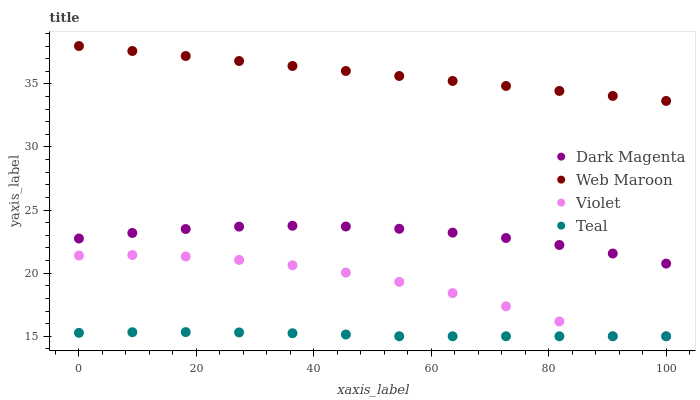Does Teal have the minimum area under the curve?
Answer yes or no. Yes. Does Web Maroon have the maximum area under the curve?
Answer yes or no. Yes. Does Dark Magenta have the minimum area under the curve?
Answer yes or no. No. Does Dark Magenta have the maximum area under the curve?
Answer yes or no. No. Is Web Maroon the smoothest?
Answer yes or no. Yes. Is Violet the roughest?
Answer yes or no. Yes. Is Dark Magenta the smoothest?
Answer yes or no. No. Is Dark Magenta the roughest?
Answer yes or no. No. Does Teal have the lowest value?
Answer yes or no. Yes. Does Dark Magenta have the lowest value?
Answer yes or no. No. Does Web Maroon have the highest value?
Answer yes or no. Yes. Does Dark Magenta have the highest value?
Answer yes or no. No. Is Teal less than Dark Magenta?
Answer yes or no. Yes. Is Web Maroon greater than Dark Magenta?
Answer yes or no. Yes. Does Teal intersect Violet?
Answer yes or no. Yes. Is Teal less than Violet?
Answer yes or no. No. Is Teal greater than Violet?
Answer yes or no. No. Does Teal intersect Dark Magenta?
Answer yes or no. No. 